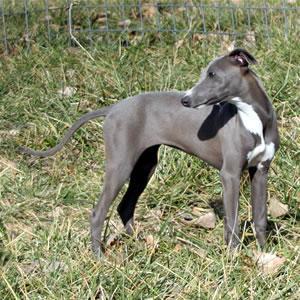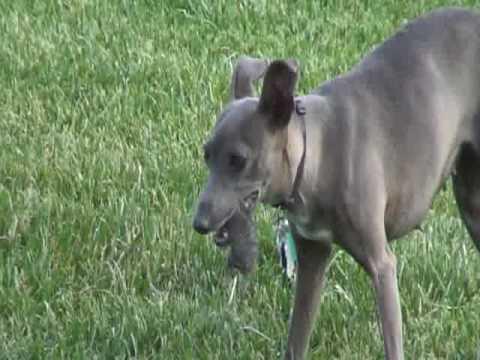The first image is the image on the left, the second image is the image on the right. For the images displayed, is the sentence "All dogs in the image pair are facing the same direction." factually correct? Answer yes or no. No. The first image is the image on the left, the second image is the image on the right. Considering the images on both sides, is "One of the paired images shows multiple black and white dogs." valid? Answer yes or no. No. The first image is the image on the left, the second image is the image on the right. Evaluate the accuracy of this statement regarding the images: "The left image contains exactly one dog.". Is it true? Answer yes or no. Yes. 